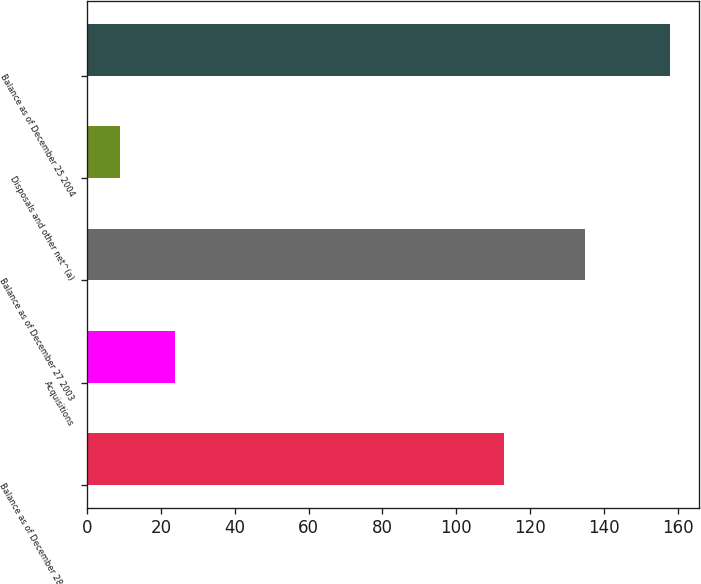<chart> <loc_0><loc_0><loc_500><loc_500><bar_chart><fcel>Balance as of December 28 2002<fcel>Acquisitions<fcel>Balance as of December 27 2003<fcel>Disposals and other net^(a)<fcel>Balance as of December 25 2004<nl><fcel>113<fcel>23.9<fcel>135<fcel>9<fcel>158<nl></chart> 